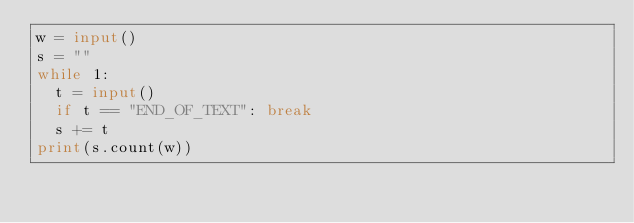Convert code to text. <code><loc_0><loc_0><loc_500><loc_500><_Python_>w = input()
s = ""
while 1:
  t = input()
  if t == "END_OF_TEXT": break
  s += t
print(s.count(w))
</code> 